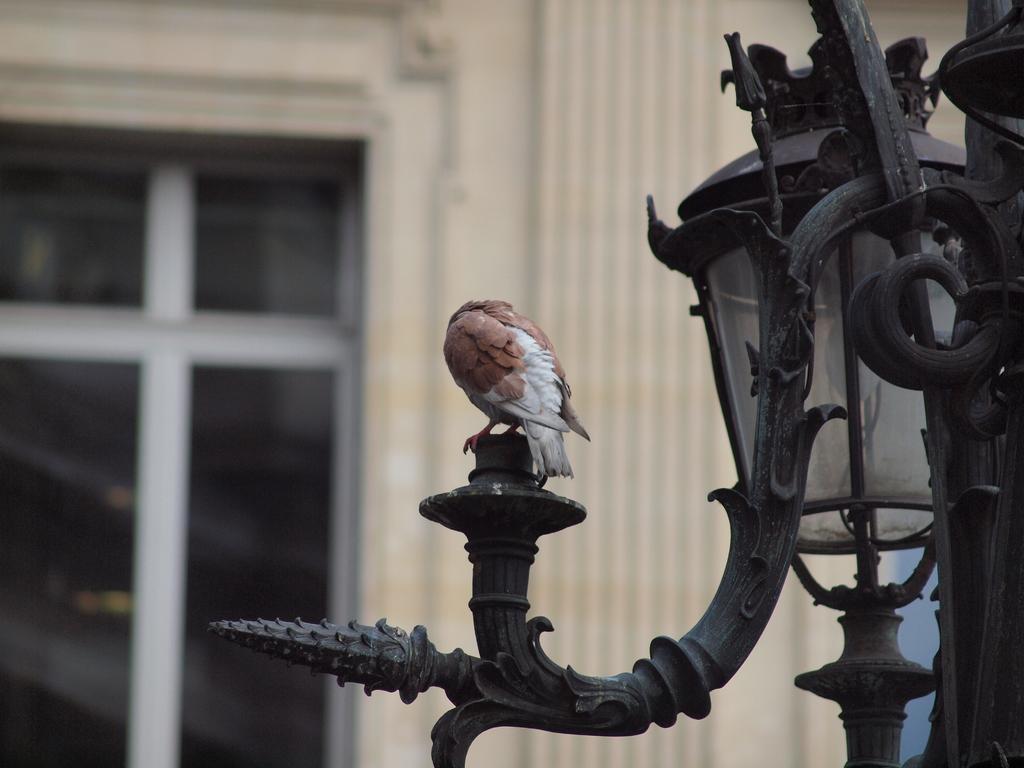Describe this image in one or two sentences. In the image we can see there is a bird standing on the street light pole handle and behind there is a building. 